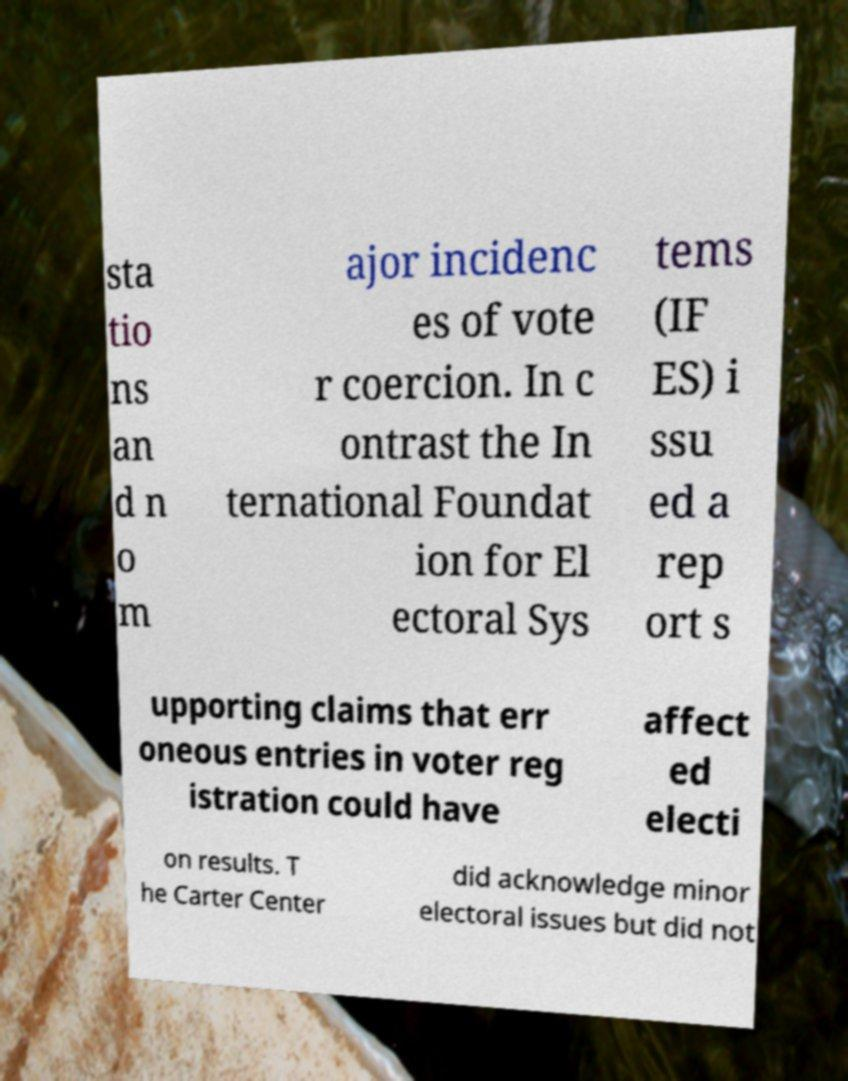Could you extract and type out the text from this image? sta tio ns an d n o m ajor incidenc es of vote r coercion. In c ontrast the In ternational Foundat ion for El ectoral Sys tems (IF ES) i ssu ed a rep ort s upporting claims that err oneous entries in voter reg istration could have affect ed electi on results. T he Carter Center did acknowledge minor electoral issues but did not 